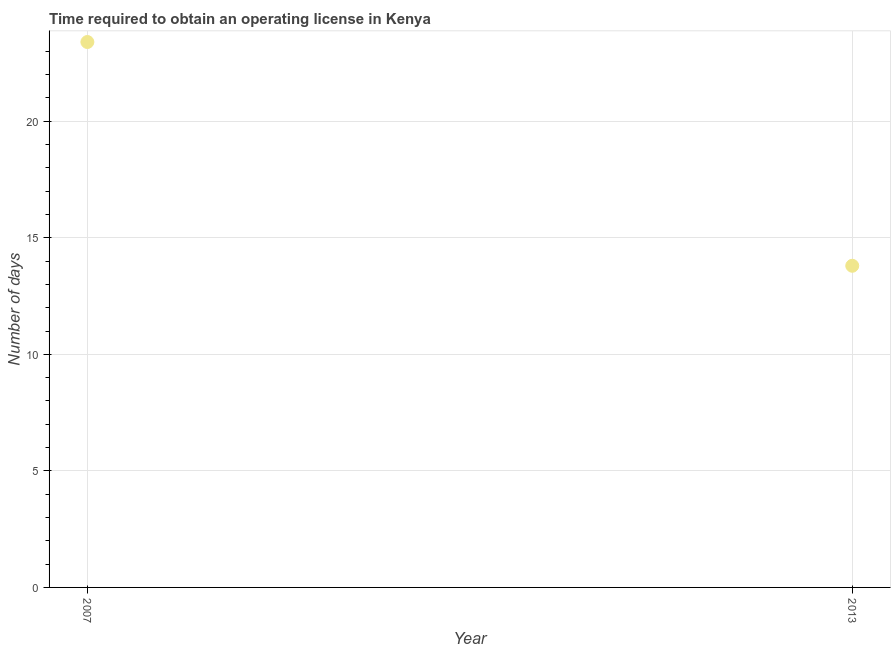What is the number of days to obtain operating license in 2007?
Give a very brief answer. 23.4. Across all years, what is the maximum number of days to obtain operating license?
Provide a short and direct response. 23.4. Across all years, what is the minimum number of days to obtain operating license?
Provide a short and direct response. 13.8. What is the sum of the number of days to obtain operating license?
Your answer should be compact. 37.2. What is the difference between the number of days to obtain operating license in 2007 and 2013?
Ensure brevity in your answer.  9.6. What is the average number of days to obtain operating license per year?
Keep it short and to the point. 18.6. What is the median number of days to obtain operating license?
Your answer should be very brief. 18.6. In how many years, is the number of days to obtain operating license greater than 9 days?
Give a very brief answer. 2. What is the ratio of the number of days to obtain operating license in 2007 to that in 2013?
Provide a short and direct response. 1.7. Is the number of days to obtain operating license in 2007 less than that in 2013?
Keep it short and to the point. No. In how many years, is the number of days to obtain operating license greater than the average number of days to obtain operating license taken over all years?
Offer a very short reply. 1. Does the number of days to obtain operating license monotonically increase over the years?
Make the answer very short. No. How many years are there in the graph?
Your answer should be compact. 2. Are the values on the major ticks of Y-axis written in scientific E-notation?
Your answer should be compact. No. Does the graph contain grids?
Offer a terse response. Yes. What is the title of the graph?
Your answer should be compact. Time required to obtain an operating license in Kenya. What is the label or title of the X-axis?
Keep it short and to the point. Year. What is the label or title of the Y-axis?
Provide a succinct answer. Number of days. What is the Number of days in 2007?
Give a very brief answer. 23.4. What is the difference between the Number of days in 2007 and 2013?
Keep it short and to the point. 9.6. What is the ratio of the Number of days in 2007 to that in 2013?
Keep it short and to the point. 1.7. 